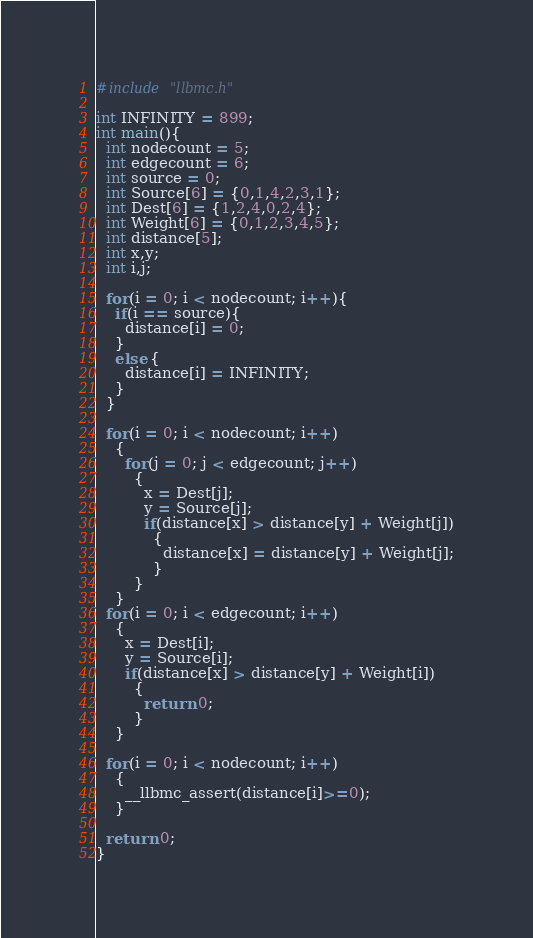Convert code to text. <code><loc_0><loc_0><loc_500><loc_500><_C_>#include "llbmc.h"

int INFINITY = 899;
int main(){
  int nodecount = 5;
  int edgecount = 6;
  int source = 0;
  int Source[6] = {0,1,4,2,3,1};
  int Dest[6] = {1,2,4,0,2,4};
  int Weight[6] = {0,1,2,3,4,5};
  int distance[5];
  int x,y;
  int i,j;

  for(i = 0; i < nodecount; i++){
    if(i == source){
      distance[i] = 0;
    }
    else {
      distance[i] = INFINITY;
    }
  }

  for(i = 0; i < nodecount; i++)
    {
      for(j = 0; j < edgecount; j++)
        {
          x = Dest[j];
          y = Source[j];
          if(distance[x] > distance[y] + Weight[j])
            {
              distance[x] = distance[y] + Weight[j];
            }
        }
    }
  for(i = 0; i < edgecount; i++)
    {
      x = Dest[i];
      y = Source[i];
      if(distance[x] > distance[y] + Weight[i])
        {
          return 0;
        }
    }

  for(i = 0; i < nodecount; i++)
    {
      __llbmc_assert(distance[i]>=0);
    }

  return 0;
}
</code> 